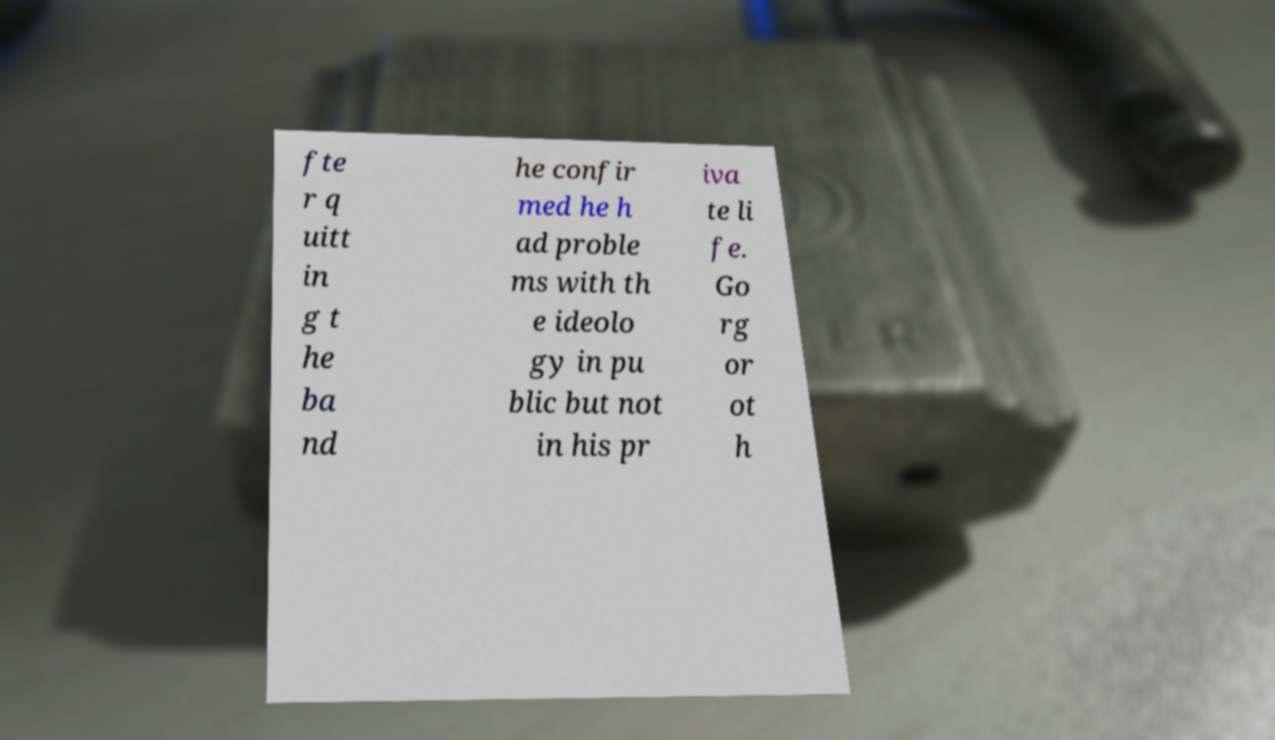Could you assist in decoding the text presented in this image and type it out clearly? fte r q uitt in g t he ba nd he confir med he h ad proble ms with th e ideolo gy in pu blic but not in his pr iva te li fe. Go rg or ot h 